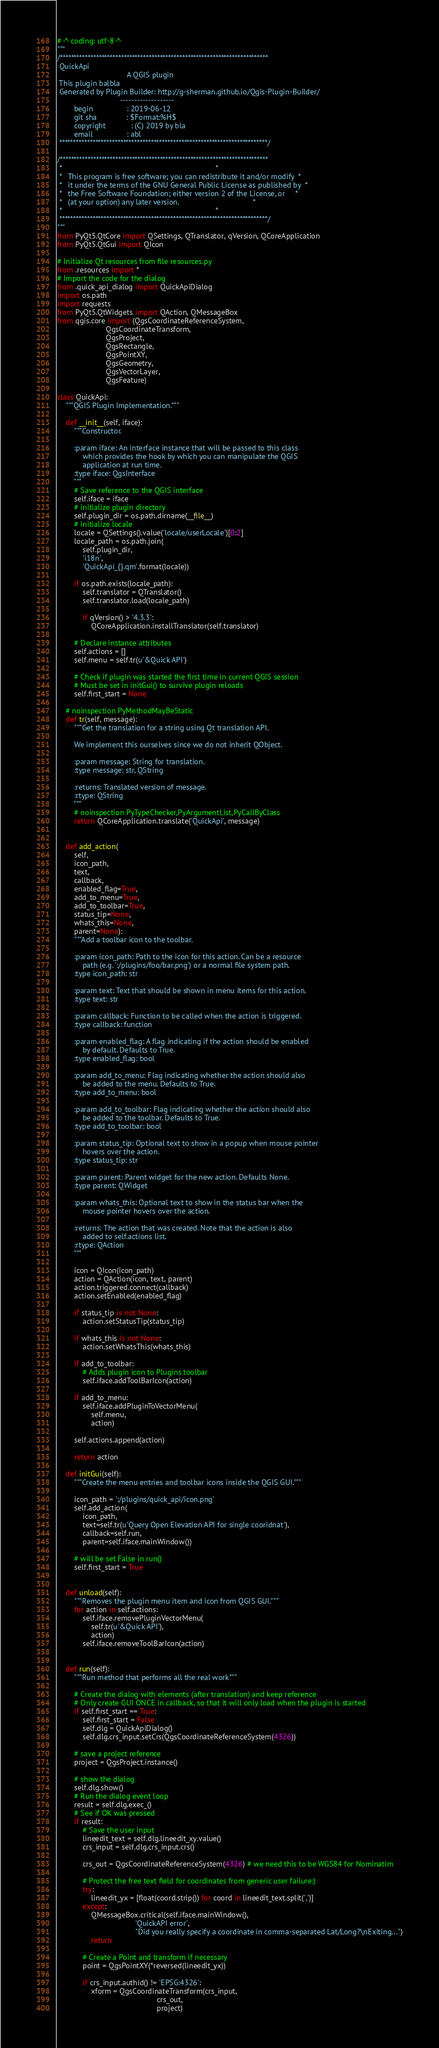<code> <loc_0><loc_0><loc_500><loc_500><_Python_># -*- coding: utf-8 -*-
"""
/***************************************************************************
 QuickApi
                                 A QGIS plugin
 This plugin balbla
 Generated by Plugin Builder: http://g-sherman.github.io/Qgis-Plugin-Builder/
                              -------------------
        begin                : 2019-06-12
        git sha              : $Format:%H$
        copyright            : (C) 2019 by bla
        email                : abl
 ***************************************************************************/

/***************************************************************************
 *                                                                         *
 *   This program is free software; you can redistribute it and/or modify  *
 *   it under the terms of the GNU General Public License as published by  *
 *   the Free Software Foundation; either version 2 of the License, or     *
 *   (at your option) any later version.                                   *
 *                                                                         *
 ***************************************************************************/
"""
from PyQt5.QtCore import QSettings, QTranslator, qVersion, QCoreApplication
from PyQt5.QtGui import QIcon

# Initialize Qt resources from file resources.py
from .resources import *
# Import the code for the dialog
from .quick_api_dialog import QuickApiDialog
import os.path
import requests
from PyQt5.QtWidgets import QAction, QMessageBox
from qgis.core import (QgsCoordinateReferenceSystem,
                       QgsCoordinateTransform,
                       QgsProject,
                       QgsRectangle,
                       QgsPointXY,
                       QgsGeometry,
                       QgsVectorLayer,
                       QgsFeature)

class QuickApi:
    """QGIS Plugin Implementation."""

    def __init__(self, iface):
        """Constructor.

        :param iface: An interface instance that will be passed to this class
            which provides the hook by which you can manipulate the QGIS
            application at run time.
        :type iface: QgsInterface
        """
        # Save reference to the QGIS interface
        self.iface = iface
        # initialize plugin directory
        self.plugin_dir = os.path.dirname(__file__)
        # initialize locale
        locale = QSettings().value('locale/userLocale')[0:2]
        locale_path = os.path.join(
            self.plugin_dir,
            'i18n',
            'QuickApi_{}.qm'.format(locale))

        if os.path.exists(locale_path):
            self.translator = QTranslator()
            self.translator.load(locale_path)

            if qVersion() > '4.3.3':
                QCoreApplication.installTranslator(self.translator)

        # Declare instance attributes
        self.actions = []
        self.menu = self.tr(u'&Quick API')

        # Check if plugin was started the first time in current QGIS session
        # Must be set in initGui() to survive plugin reloads
        self.first_start = None

    # noinspection PyMethodMayBeStatic
    def tr(self, message):
        """Get the translation for a string using Qt translation API.

        We implement this ourselves since we do not inherit QObject.

        :param message: String for translation.
        :type message: str, QString

        :returns: Translated version of message.
        :rtype: QString
        """
        # noinspection PyTypeChecker,PyArgumentList,PyCallByClass
        return QCoreApplication.translate('QuickApi', message)


    def add_action(
        self,
        icon_path,
        text,
        callback,
        enabled_flag=True,
        add_to_menu=True,
        add_to_toolbar=True,
        status_tip=None,
        whats_this=None,
        parent=None):
        """Add a toolbar icon to the toolbar.

        :param icon_path: Path to the icon for this action. Can be a resource
            path (e.g. ':/plugins/foo/bar.png') or a normal file system path.
        :type icon_path: str

        :param text: Text that should be shown in menu items for this action.
        :type text: str

        :param callback: Function to be called when the action is triggered.
        :type callback: function

        :param enabled_flag: A flag indicating if the action should be enabled
            by default. Defaults to True.
        :type enabled_flag: bool

        :param add_to_menu: Flag indicating whether the action should also
            be added to the menu. Defaults to True.
        :type add_to_menu: bool

        :param add_to_toolbar: Flag indicating whether the action should also
            be added to the toolbar. Defaults to True.
        :type add_to_toolbar: bool

        :param status_tip: Optional text to show in a popup when mouse pointer
            hovers over the action.
        :type status_tip: str

        :param parent: Parent widget for the new action. Defaults None.
        :type parent: QWidget

        :param whats_this: Optional text to show in the status bar when the
            mouse pointer hovers over the action.

        :returns: The action that was created. Note that the action is also
            added to self.actions list.
        :rtype: QAction
        """

        icon = QIcon(icon_path)
        action = QAction(icon, text, parent)
        action.triggered.connect(callback)
        action.setEnabled(enabled_flag)

        if status_tip is not None:
            action.setStatusTip(status_tip)

        if whats_this is not None:
            action.setWhatsThis(whats_this)

        if add_to_toolbar:
            # Adds plugin icon to Plugins toolbar
            self.iface.addToolBarIcon(action)

        if add_to_menu:
            self.iface.addPluginToVectorMenu(
                self.menu,
                action)

        self.actions.append(action)

        return action

    def initGui(self):
        """Create the menu entries and toolbar icons inside the QGIS GUI."""

        icon_path = ':/plugins/quick_api/icon.png'
        self.add_action(
            icon_path,
            text=self.tr(u'Query Open Elevation API for single cooridnat'),
            callback=self.run,
            parent=self.iface.mainWindow())

        # will be set False in run()
        self.first_start = True


    def unload(self):
        """Removes the plugin menu item and icon from QGIS GUI."""
        for action in self.actions:
            self.iface.removePluginVectorMenu(
                self.tr(u'&Quick API'),
                action)
            self.iface.removeToolBarIcon(action)


    def run(self):
        """Run method that performs all the real work"""

        # Create the dialog with elements (after translation) and keep reference
        # Only create GUI ONCE in callback, so that it will only load when the plugin is started
        if self.first_start == True:
            self.first_start = False
            self.dlg = QuickApiDialog()
            self.dlg.crs_input.setCrs(QgsCoordinateReferenceSystem(4326))

        # save a project reference
        project = QgsProject.instance()

        # show the dialog
        self.dlg.show()
        # Run the dialog event loop
        result = self.dlg.exec_()
        # See if OK was pressed
        if result:
            # Save the user input
            lineedit_text = self.dlg.lineedit_xy.value()
            crs_input = self.dlg.crs_input.crs()

            crs_out = QgsCoordinateReferenceSystem(4326) # we need this to be WGS84 for Nominatim

            # Protect the free text field for coordinates from generic user failure:)
            try:
                lineedit_yx = [float(coord.strip()) for coord in lineedit_text.split(',')]
            except:
                QMessageBox.critical(self.iface.mainWindow(),
                                     'QuickAPI error',
                                     "Did you really specify a coordinate in comma-separated Lat/Long?\nExiting...")
                return

            # Create a Point and transform if necessary
            point = QgsPointXY(*reversed(lineedit_yx))

            if crs_input.authid() != 'EPSG:4326':
                xform = QgsCoordinateTransform(crs_input,
                                               crs_out,
                                               project)</code> 